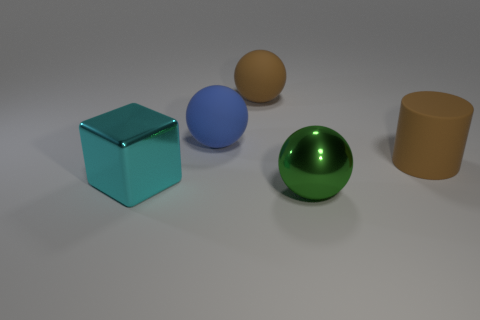Does the big brown object to the right of the green shiny thing have the same material as the big brown object to the left of the big brown cylinder?
Keep it short and to the point. Yes. What color is the ball that is made of the same material as the large blue thing?
Give a very brief answer. Brown. How many metal cubes have the same size as the brown ball?
Offer a terse response. 1. How many other things are there of the same color as the big rubber cylinder?
Give a very brief answer. 1. Are there any other things that have the same size as the blue rubber object?
Offer a very short reply. Yes. Is the shape of the large rubber thing that is behind the blue thing the same as the large brown rubber object that is right of the large metallic ball?
Your answer should be compact. No. What shape is the cyan object that is the same size as the brown rubber cylinder?
Give a very brief answer. Cube. Are there the same number of cyan shiny cubes behind the cyan metallic block and big objects that are on the left side of the cylinder?
Give a very brief answer. No. Is there any other thing that has the same shape as the green thing?
Ensure brevity in your answer.  Yes. Do the object in front of the cyan thing and the cube have the same material?
Give a very brief answer. Yes. 